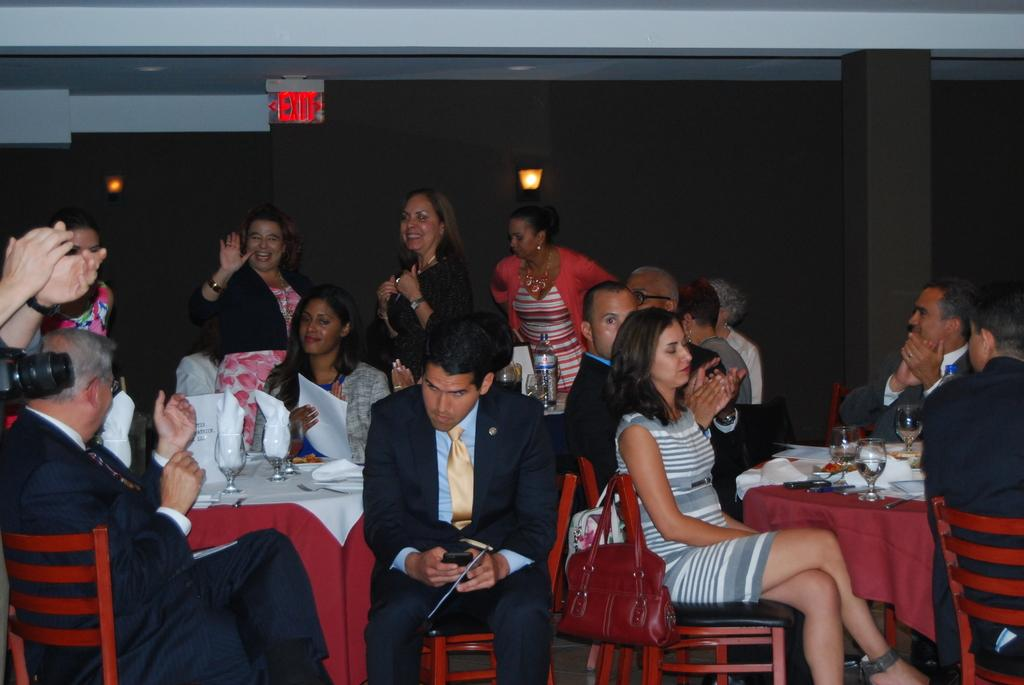<image>
Relay a brief, clear account of the picture shown. People at a function sit in red chairs under a red exit sign. 